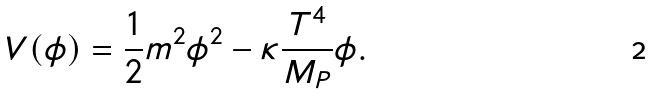Convert formula to latex. <formula><loc_0><loc_0><loc_500><loc_500>V ( \phi ) = \frac { 1 } { 2 } m ^ { 2 } \phi ^ { 2 } - \kappa \frac { T ^ { 4 } } { M _ { P } } \phi .</formula> 